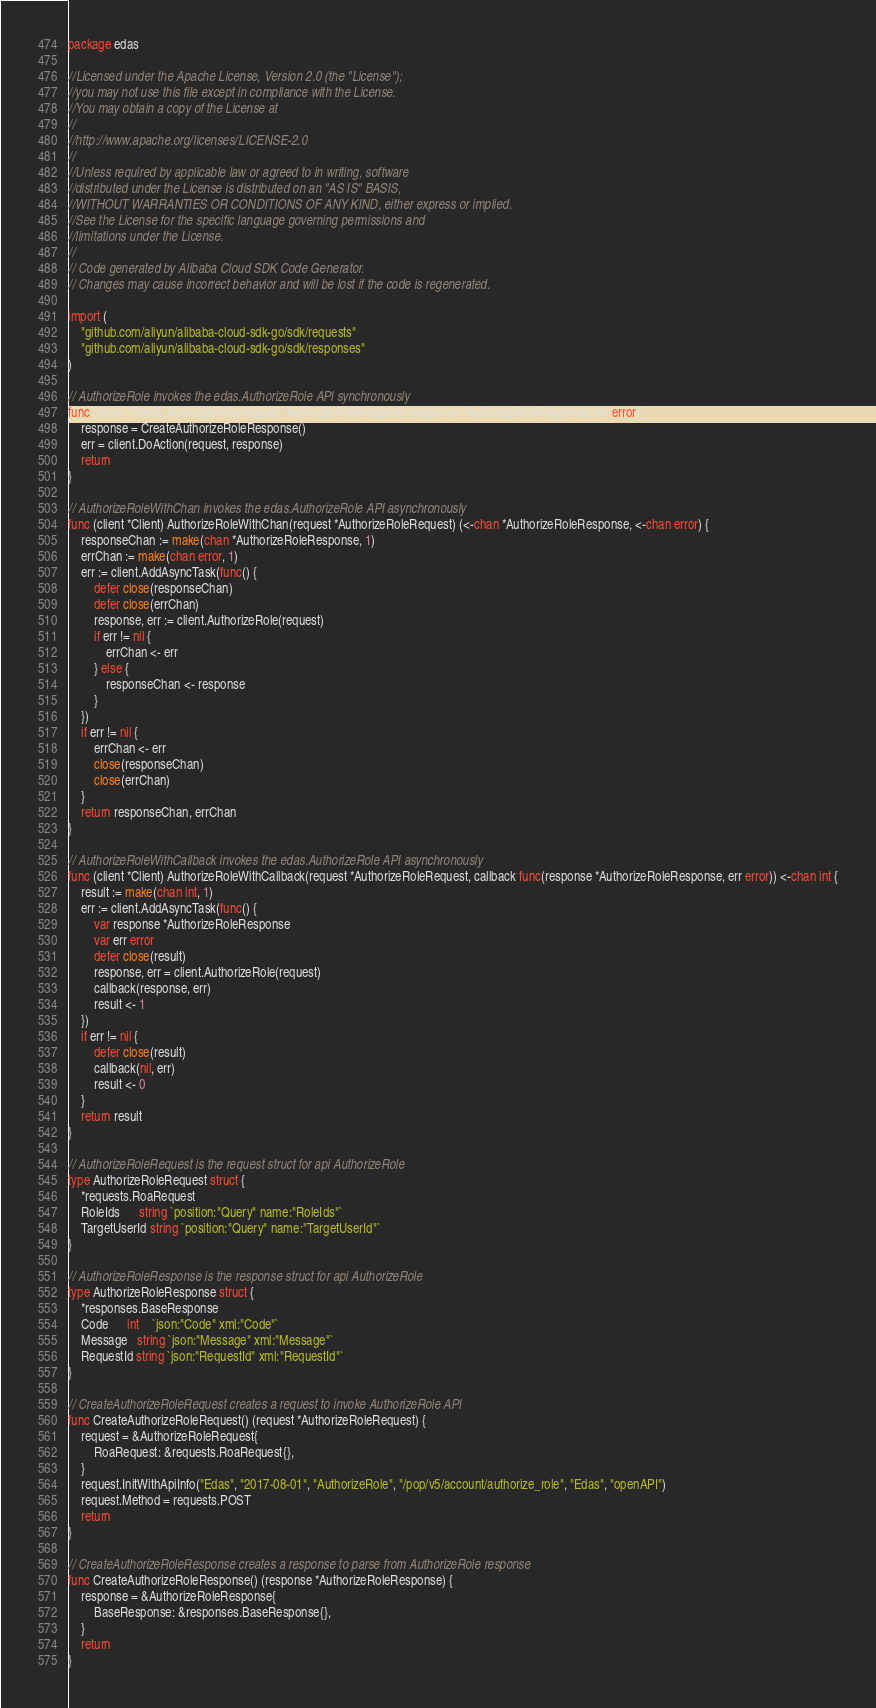Convert code to text. <code><loc_0><loc_0><loc_500><loc_500><_Go_>package edas

//Licensed under the Apache License, Version 2.0 (the "License");
//you may not use this file except in compliance with the License.
//You may obtain a copy of the License at
//
//http://www.apache.org/licenses/LICENSE-2.0
//
//Unless required by applicable law or agreed to in writing, software
//distributed under the License is distributed on an "AS IS" BASIS,
//WITHOUT WARRANTIES OR CONDITIONS OF ANY KIND, either express or implied.
//See the License for the specific language governing permissions and
//limitations under the License.
//
// Code generated by Alibaba Cloud SDK Code Generator.
// Changes may cause incorrect behavior and will be lost if the code is regenerated.

import (
	"github.com/aliyun/alibaba-cloud-sdk-go/sdk/requests"
	"github.com/aliyun/alibaba-cloud-sdk-go/sdk/responses"
)

// AuthorizeRole invokes the edas.AuthorizeRole API synchronously
func (client *Client) AuthorizeRole(request *AuthorizeRoleRequest) (response *AuthorizeRoleResponse, err error) {
	response = CreateAuthorizeRoleResponse()
	err = client.DoAction(request, response)
	return
}

// AuthorizeRoleWithChan invokes the edas.AuthorizeRole API asynchronously
func (client *Client) AuthorizeRoleWithChan(request *AuthorizeRoleRequest) (<-chan *AuthorizeRoleResponse, <-chan error) {
	responseChan := make(chan *AuthorizeRoleResponse, 1)
	errChan := make(chan error, 1)
	err := client.AddAsyncTask(func() {
		defer close(responseChan)
		defer close(errChan)
		response, err := client.AuthorizeRole(request)
		if err != nil {
			errChan <- err
		} else {
			responseChan <- response
		}
	})
	if err != nil {
		errChan <- err
		close(responseChan)
		close(errChan)
	}
	return responseChan, errChan
}

// AuthorizeRoleWithCallback invokes the edas.AuthorizeRole API asynchronously
func (client *Client) AuthorizeRoleWithCallback(request *AuthorizeRoleRequest, callback func(response *AuthorizeRoleResponse, err error)) <-chan int {
	result := make(chan int, 1)
	err := client.AddAsyncTask(func() {
		var response *AuthorizeRoleResponse
		var err error
		defer close(result)
		response, err = client.AuthorizeRole(request)
		callback(response, err)
		result <- 1
	})
	if err != nil {
		defer close(result)
		callback(nil, err)
		result <- 0
	}
	return result
}

// AuthorizeRoleRequest is the request struct for api AuthorizeRole
type AuthorizeRoleRequest struct {
	*requests.RoaRequest
	RoleIds      string `position:"Query" name:"RoleIds"`
	TargetUserId string `position:"Query" name:"TargetUserId"`
}

// AuthorizeRoleResponse is the response struct for api AuthorizeRole
type AuthorizeRoleResponse struct {
	*responses.BaseResponse
	Code      int    `json:"Code" xml:"Code"`
	Message   string `json:"Message" xml:"Message"`
	RequestId string `json:"RequestId" xml:"RequestId"`
}

// CreateAuthorizeRoleRequest creates a request to invoke AuthorizeRole API
func CreateAuthorizeRoleRequest() (request *AuthorizeRoleRequest) {
	request = &AuthorizeRoleRequest{
		RoaRequest: &requests.RoaRequest{},
	}
	request.InitWithApiInfo("Edas", "2017-08-01", "AuthorizeRole", "/pop/v5/account/authorize_role", "Edas", "openAPI")
	request.Method = requests.POST
	return
}

// CreateAuthorizeRoleResponse creates a response to parse from AuthorizeRole response
func CreateAuthorizeRoleResponse() (response *AuthorizeRoleResponse) {
	response = &AuthorizeRoleResponse{
		BaseResponse: &responses.BaseResponse{},
	}
	return
}
</code> 